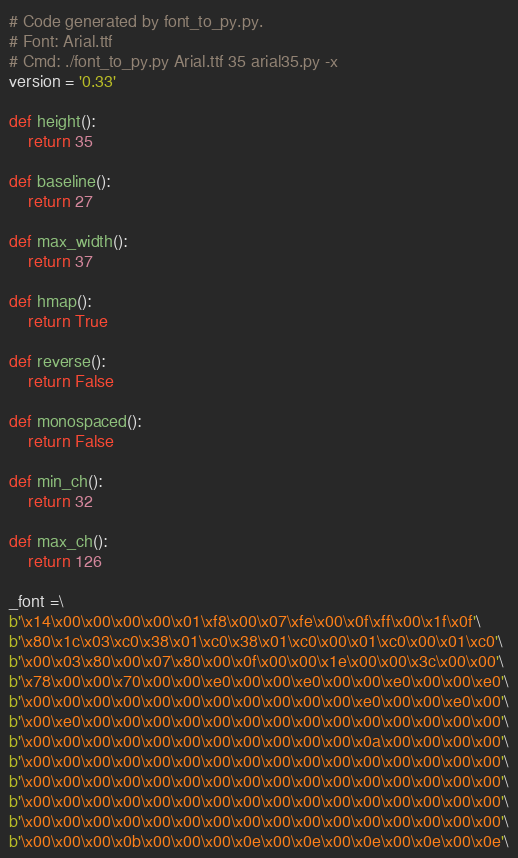<code> <loc_0><loc_0><loc_500><loc_500><_Python_># Code generated by font_to_py.py.
# Font: Arial.ttf
# Cmd: ./font_to_py.py Arial.ttf 35 arial35.py -x
version = '0.33'

def height():
    return 35

def baseline():
    return 27

def max_width():
    return 37

def hmap():
    return True

def reverse():
    return False

def monospaced():
    return False

def min_ch():
    return 32

def max_ch():
    return 126

_font =\
b'\x14\x00\x00\x00\x00\x01\xf8\x00\x07\xfe\x00\x0f\xff\x00\x1f\x0f'\
b'\x80\x1c\x03\xc0\x38\x01\xc0\x38\x01\xc0\x00\x01\xc0\x00\x01\xc0'\
b'\x00\x03\x80\x00\x07\x80\x00\x0f\x00\x00\x1e\x00\x00\x3c\x00\x00'\
b'\x78\x00\x00\x70\x00\x00\xe0\x00\x00\xe0\x00\x00\xe0\x00\x00\xe0'\
b'\x00\x00\x00\x00\x00\x00\x00\x00\x00\x00\x00\xe0\x00\x00\xe0\x00'\
b'\x00\xe0\x00\x00\x00\x00\x00\x00\x00\x00\x00\x00\x00\x00\x00\x00'\
b'\x00\x00\x00\x00\x00\x00\x00\x00\x00\x00\x00\x0a\x00\x00\x00\x00'\
b'\x00\x00\x00\x00\x00\x00\x00\x00\x00\x00\x00\x00\x00\x00\x00\x00'\
b'\x00\x00\x00\x00\x00\x00\x00\x00\x00\x00\x00\x00\x00\x00\x00\x00'\
b'\x00\x00\x00\x00\x00\x00\x00\x00\x00\x00\x00\x00\x00\x00\x00\x00'\
b'\x00\x00\x00\x00\x00\x00\x00\x00\x00\x00\x00\x00\x00\x00\x00\x00'\
b'\x00\x00\x00\x0b\x00\x00\x00\x0e\x00\x0e\x00\x0e\x00\x0e\x00\x0e'\</code> 